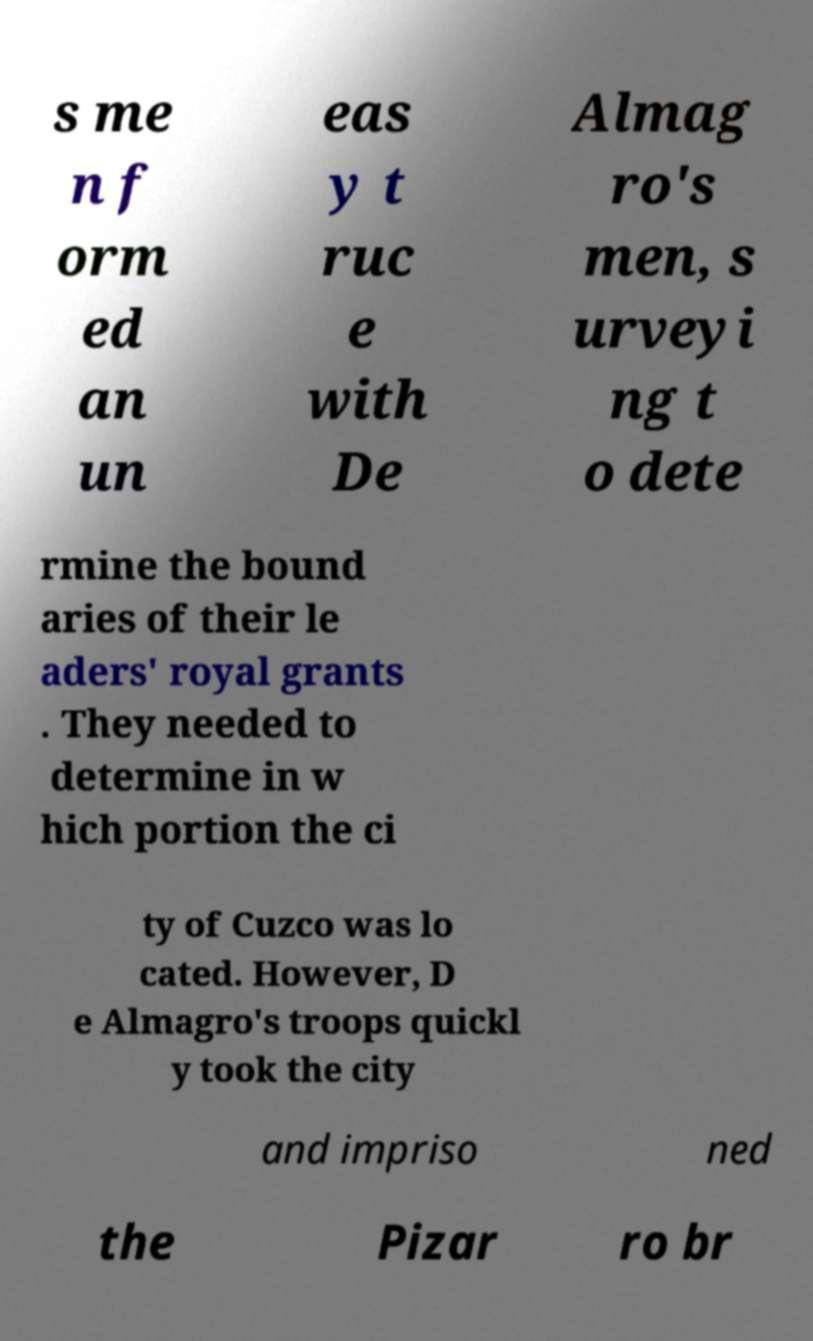Could you extract and type out the text from this image? s me n f orm ed an un eas y t ruc e with De Almag ro's men, s urveyi ng t o dete rmine the bound aries of their le aders' royal grants . They needed to determine in w hich portion the ci ty of Cuzco was lo cated. However, D e Almagro's troops quickl y took the city and impriso ned the Pizar ro br 